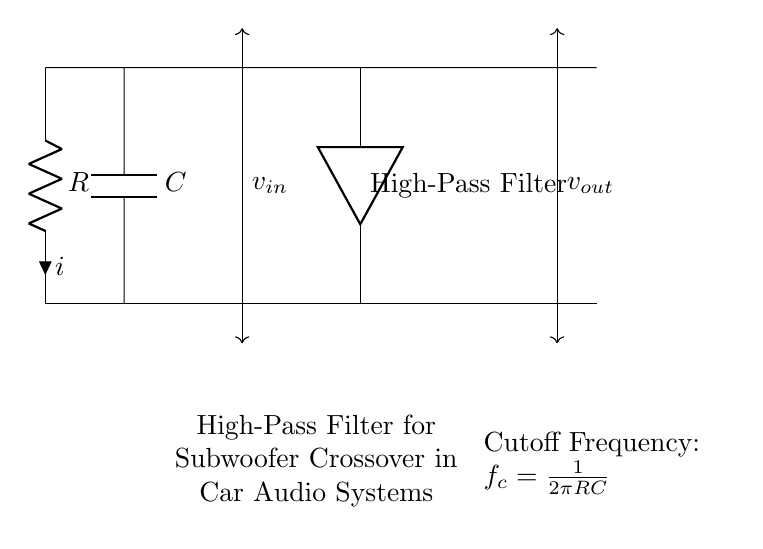What is the type of filter shown in the diagram? The circuit is labeled as a "High-Pass Filter," which indicates that it allows high frequencies to pass through while attenuating lower frequencies.
Answer: High-Pass Filter What components are present in the circuit? The circuit contains a resistor (R) and a capacitor (C), which are fundamental components for creating a high-pass filter.
Answer: Resistor and Capacitor What is the input voltage variable labeled in the diagram? The input voltage is represented as "v_in" which is the voltage applied to the circuit.
Answer: v_in What is the output voltage variable labeled in the diagram? The output voltage is designated as "v_out," indicating the voltage across the output of the filter circuit.
Answer: v_out How is the cutoff frequency calculated? The cutoff frequency is calculated using the formula \( f_c = \frac{1}{2\pi RC} \), indicating that it depends on the values of the resistor and capacitor.
Answer: \( f_c = \frac{1}{2\pi RC} \) What happens to frequencies below the cutoff frequency? Frequencies below the cutoff frequency are attenuated, meaning they are reduced in amplitude as they pass through the filter.
Answer: Attenuated What role does the capacitor play in this circuit? The capacitor allows higher frequency signals to pass while blocking lower frequency signals, which is essential for the function of a high-pass filter.
Answer: Allows high frequencies 